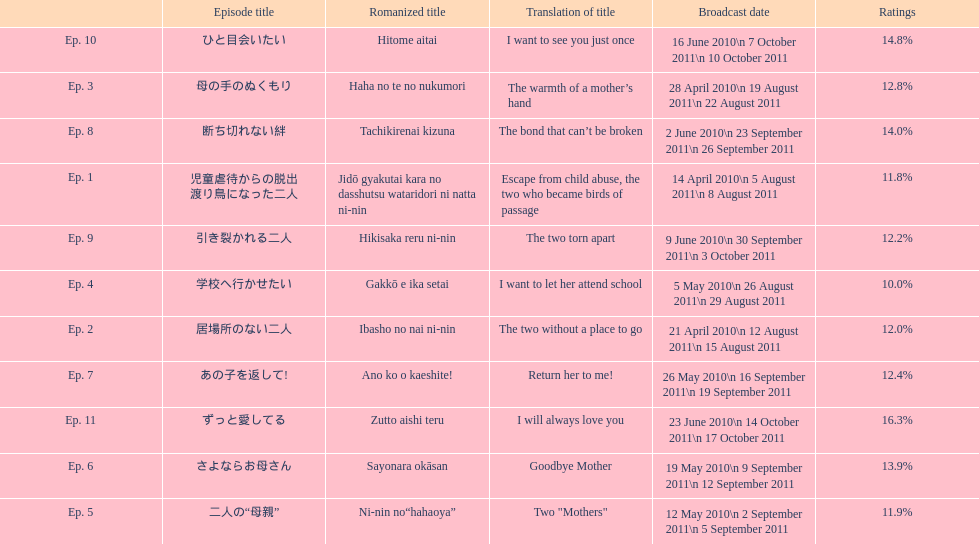What was the name of the next episode after goodbye mother? あの子を返して!. 